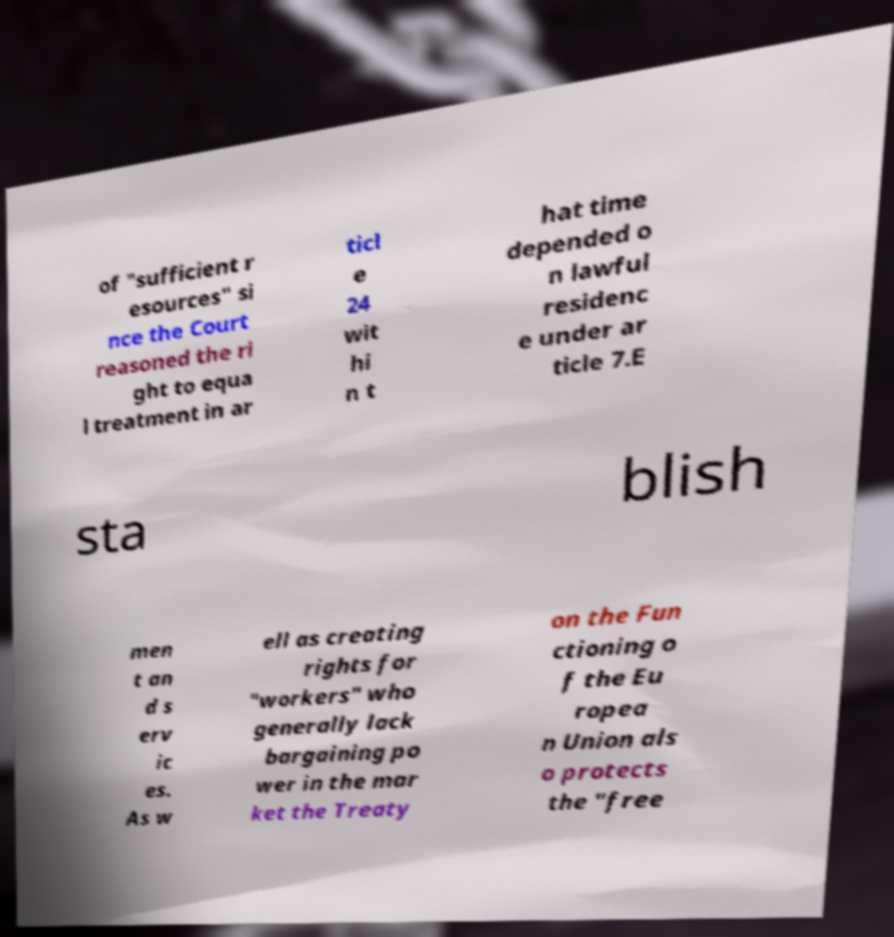Can you accurately transcribe the text from the provided image for me? of "sufficient r esources" si nce the Court reasoned the ri ght to equa l treatment in ar ticl e 24 wit hi n t hat time depended o n lawful residenc e under ar ticle 7.E sta blish men t an d s erv ic es. As w ell as creating rights for "workers" who generally lack bargaining po wer in the mar ket the Treaty on the Fun ctioning o f the Eu ropea n Union als o protects the "free 